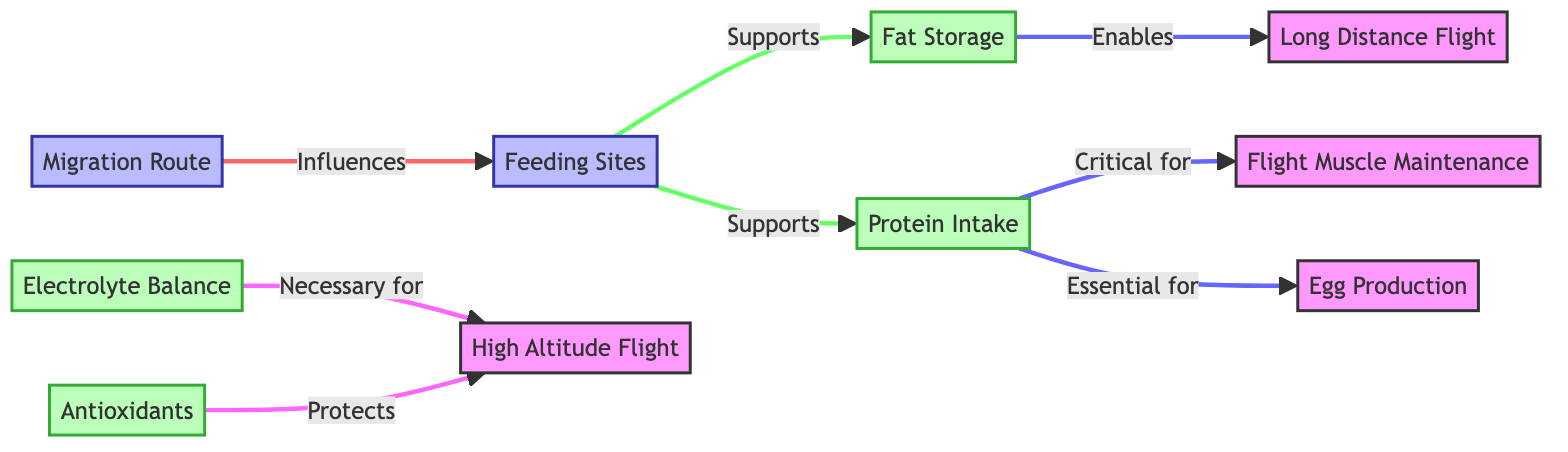What do feeding sites support? The diagram illustrates that feeding sites support fat storage and protein intake. Specifically, there are two arrows pointing from feeding sites to both fat storage and protein intake nodes.
Answer: fat storage, protein intake How many nutrition aspects are listed? In the diagram, there are four nutrition aspects represented as nodes: fat storage, protein intake, electrolyte balance, and antioxidants. Thus, counting these nodes gives a total of four.
Answer: 4 What is critical for flight muscle maintenance? The diagram indicates that protein intake is critical for flight muscle maintenance, as it directly connects to that node with an arrow denoting its importance.
Answer: protein intake Which nutritional requirement is necessary for high altitude flight? The diagram specifies that electrolyte balance is necessary for high altitude flight, since there is a direct arrow showing its necessity from the electrolyte balance node.
Answer: electrolyte balance What does fat storage enable? According to the diagram, fat storage enables long distance flight, as indicated by the directed arrow from fat storage to the long distance flight node.
Answer: long distance flight Which component protects high altitude flight? The diagram clearly denotes that antioxidants protect high altitude flight. This is shown by the arrow connecting the antioxidants node to the high altitude flight node.
Answer: antioxidants How does migration route influence feeding sites? The migration route influences feeding sites as depicted by a directed arrow pointing from the migration route node to the feeding sites node. This indicates the relationship where the migration route has an impact on where feeding sites are located.
Answer: influences How is protein intake essential for egg production? The diagram indicates that protein intake is essential for egg production. This relationship is depicted with a direct arrow from protein intake to egg production, highlighting that without adequate protein, egg production may be compromised.
Answer: egg production What is indicated by the link from fat storage? The link from fat storage to long distance flight indicates that fat storage is a requirement that enables birds to undertake long distance flights. The diagrams illustrate this direction with clarity, emphasizing the dependency of long distance flight on fat storage.
Answer: enables long distance flight 